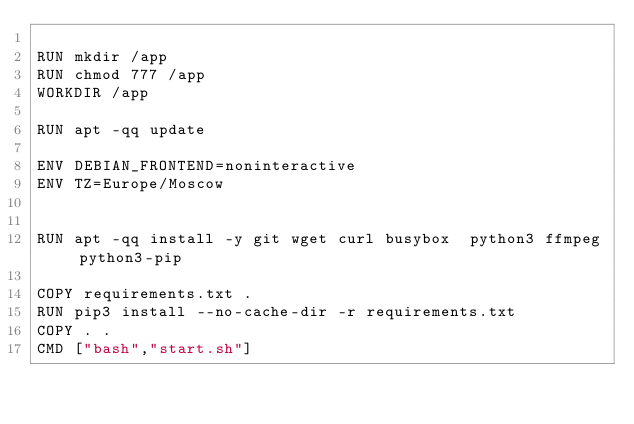<code> <loc_0><loc_0><loc_500><loc_500><_Dockerfile_>
RUN mkdir /app
RUN chmod 777 /app
WORKDIR /app

RUN apt -qq update

ENV DEBIAN_FRONTEND=noninteractive
ENV TZ=Europe/Moscow


RUN apt -qq install -y git wget curl busybox  python3 ffmpeg python3-pip

COPY requirements.txt .
RUN pip3 install --no-cache-dir -r requirements.txt
COPY . .
CMD ["bash","start.sh"]
</code> 